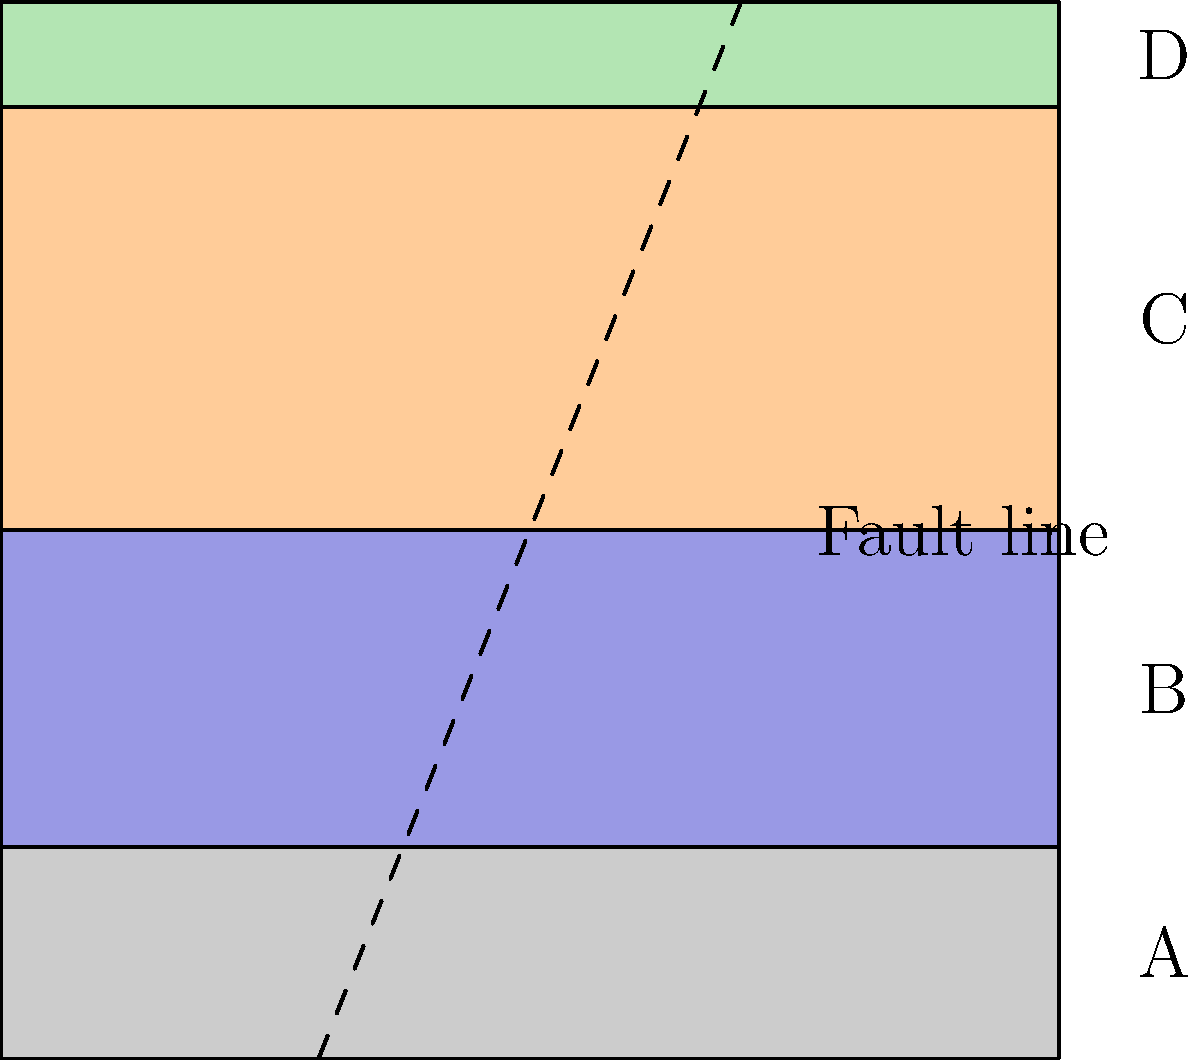Based on the cross-sectional diagram of geological formations, which clustering approach would be most appropriate for grouping these layers, and why? To determine the most appropriate clustering approach for grouping the geological layers in the given cross-sectional diagram, we need to consider the following factors:

1. Spatial distribution: The layers are clearly stratified and have distinct boundaries.
2. Continuity: There is a fault line cutting across the layers, disrupting their continuity.
3. Number of clusters: There are four visually distinct layers (A, B, C, and D).
4. Shape of clusters: The layers have irregular shapes due to the fault line.

Given these characteristics, the most appropriate clustering approach would be Hierarchical Clustering, specifically Agglomerative Hierarchical Clustering. Here's why:

1. Hierarchical Clustering can handle spatial data and does not require a predefined number of clusters.
2. It can capture the natural hierarchy in the geological formations, where layers are nested within larger structures.
3. Agglomerative Hierarchical Clustering starts with each data point as a separate cluster and then merges similar clusters, which aligns well with the process of identifying distinct layers and their relationships.
4. This method can accommodate the irregular shapes of the layers caused by the fault line.
5. It allows for the creation of a dendrogram, which can visually represent the relationships between layers and sub-layers.
6. Hierarchical Clustering is not sensitive to the initial conditions, which is important given the complex structure of the geological formations.

Other clustering methods, such as K-means, would be less suitable because:
- K-means assumes spherical clusters, which doesn't match the elongated shape of the layers.
- It requires a predefined number of clusters, which may not capture the hierarchical nature of geological formations.
- K-means is sensitive to the presence of outliers, which could be problematic with the fault line disrupting the layer continuity.

In conclusion, Agglomerative Hierarchical Clustering would be the most appropriate approach for grouping these geological layers, as it can capture the spatial relationships, handle the irregular shapes, and represent the hierarchical nature of the formations.
Answer: Agglomerative Hierarchical Clustering 